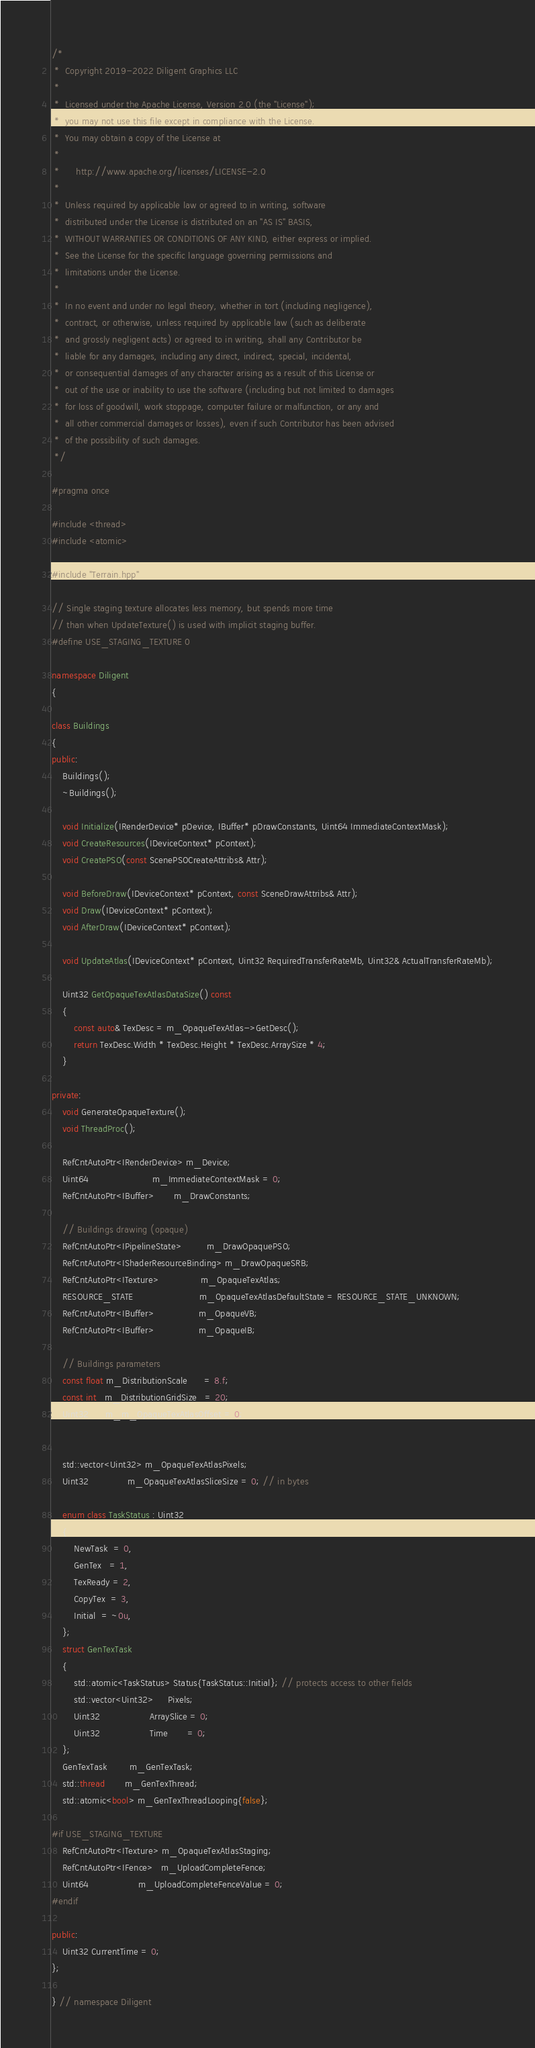<code> <loc_0><loc_0><loc_500><loc_500><_C++_>/*
 *  Copyright 2019-2022 Diligent Graphics LLC
 *  
 *  Licensed under the Apache License, Version 2.0 (the "License");
 *  you may not use this file except in compliance with the License.
 *  You may obtain a copy of the License at
 *  
 *      http://www.apache.org/licenses/LICENSE-2.0
 *  
 *  Unless required by applicable law or agreed to in writing, software
 *  distributed under the License is distributed on an "AS IS" BASIS,
 *  WITHOUT WARRANTIES OR CONDITIONS OF ANY KIND, either express or implied.
 *  See the License for the specific language governing permissions and
 *  limitations under the License.
 *
 *  In no event and under no legal theory, whether in tort (including negligence), 
 *  contract, or otherwise, unless required by applicable law (such as deliberate 
 *  and grossly negligent acts) or agreed to in writing, shall any Contributor be
 *  liable for any damages, including any direct, indirect, special, incidental, 
 *  or consequential damages of any character arising as a result of this License or 
 *  out of the use or inability to use the software (including but not limited to damages 
 *  for loss of goodwill, work stoppage, computer failure or malfunction, or any and 
 *  all other commercial damages or losses), even if such Contributor has been advised 
 *  of the possibility of such damages.
 */

#pragma once

#include <thread>
#include <atomic>

#include "Terrain.hpp"

// Single staging texture allocates less memory, but spends more time
// than when UpdateTexture() is used with implicit staging buffer.
#define USE_STAGING_TEXTURE 0

namespace Diligent
{

class Buildings
{
public:
    Buildings();
    ~Buildings();

    void Initialize(IRenderDevice* pDevice, IBuffer* pDrawConstants, Uint64 ImmediateContextMask);
    void CreateResources(IDeviceContext* pContext);
    void CreatePSO(const ScenePSOCreateAttribs& Attr);

    void BeforeDraw(IDeviceContext* pContext, const SceneDrawAttribs& Attr);
    void Draw(IDeviceContext* pContext);
    void AfterDraw(IDeviceContext* pContext);

    void UpdateAtlas(IDeviceContext* pContext, Uint32 RequiredTransferRateMb, Uint32& ActualTransferRateMb);

    Uint32 GetOpaqueTexAtlasDataSize() const
    {
        const auto& TexDesc = m_OpaqueTexAtlas->GetDesc();
        return TexDesc.Width * TexDesc.Height * TexDesc.ArraySize * 4;
    }

private:
    void GenerateOpaqueTexture();
    void ThreadProc();

    RefCntAutoPtr<IRenderDevice> m_Device;
    Uint64                       m_ImmediateContextMask = 0;
    RefCntAutoPtr<IBuffer>       m_DrawConstants;

    // Buildings drawing (opaque)
    RefCntAutoPtr<IPipelineState>         m_DrawOpaquePSO;
    RefCntAutoPtr<IShaderResourceBinding> m_DrawOpaqueSRB;
    RefCntAutoPtr<ITexture>               m_OpaqueTexAtlas;
    RESOURCE_STATE                        m_OpaqueTexAtlasDefaultState = RESOURCE_STATE_UNKNOWN;
    RefCntAutoPtr<IBuffer>                m_OpaqueVB;
    RefCntAutoPtr<IBuffer>                m_OpaqueIB;

    // Buildings parameters
    const float m_DistributionScale      = 8.f;
    const int   m_DistributionGridSize   = 20;
    Uint32      m_m_OpaqueTexAtlasOffset = 0;


    std::vector<Uint32> m_OpaqueTexAtlasPixels;
    Uint32              m_OpaqueTexAtlasSliceSize = 0; // in bytes

    enum class TaskStatus : Uint32
    {
        NewTask  = 0,
        GenTex   = 1,
        TexReady = 2,
        CopyTex  = 3,
        Initial  = ~0u,
    };
    struct GenTexTask
    {
        std::atomic<TaskStatus> Status{TaskStatus::Initial}; // protects access to other fields
        std::vector<Uint32>     Pixels;
        Uint32                  ArraySlice = 0;
        Uint32                  Time       = 0;
    };
    GenTexTask        m_GenTexTask;
    std::thread       m_GenTexThread;
    std::atomic<bool> m_GenTexThreadLooping{false};

#if USE_STAGING_TEXTURE
    RefCntAutoPtr<ITexture> m_OpaqueTexAtlasStaging;
    RefCntAutoPtr<IFence>   m_UploadCompleteFence;
    Uint64                  m_UploadCompleteFenceValue = 0;
#endif

public:
    Uint32 CurrentTime = 0;
};

} // namespace Diligent
</code> 